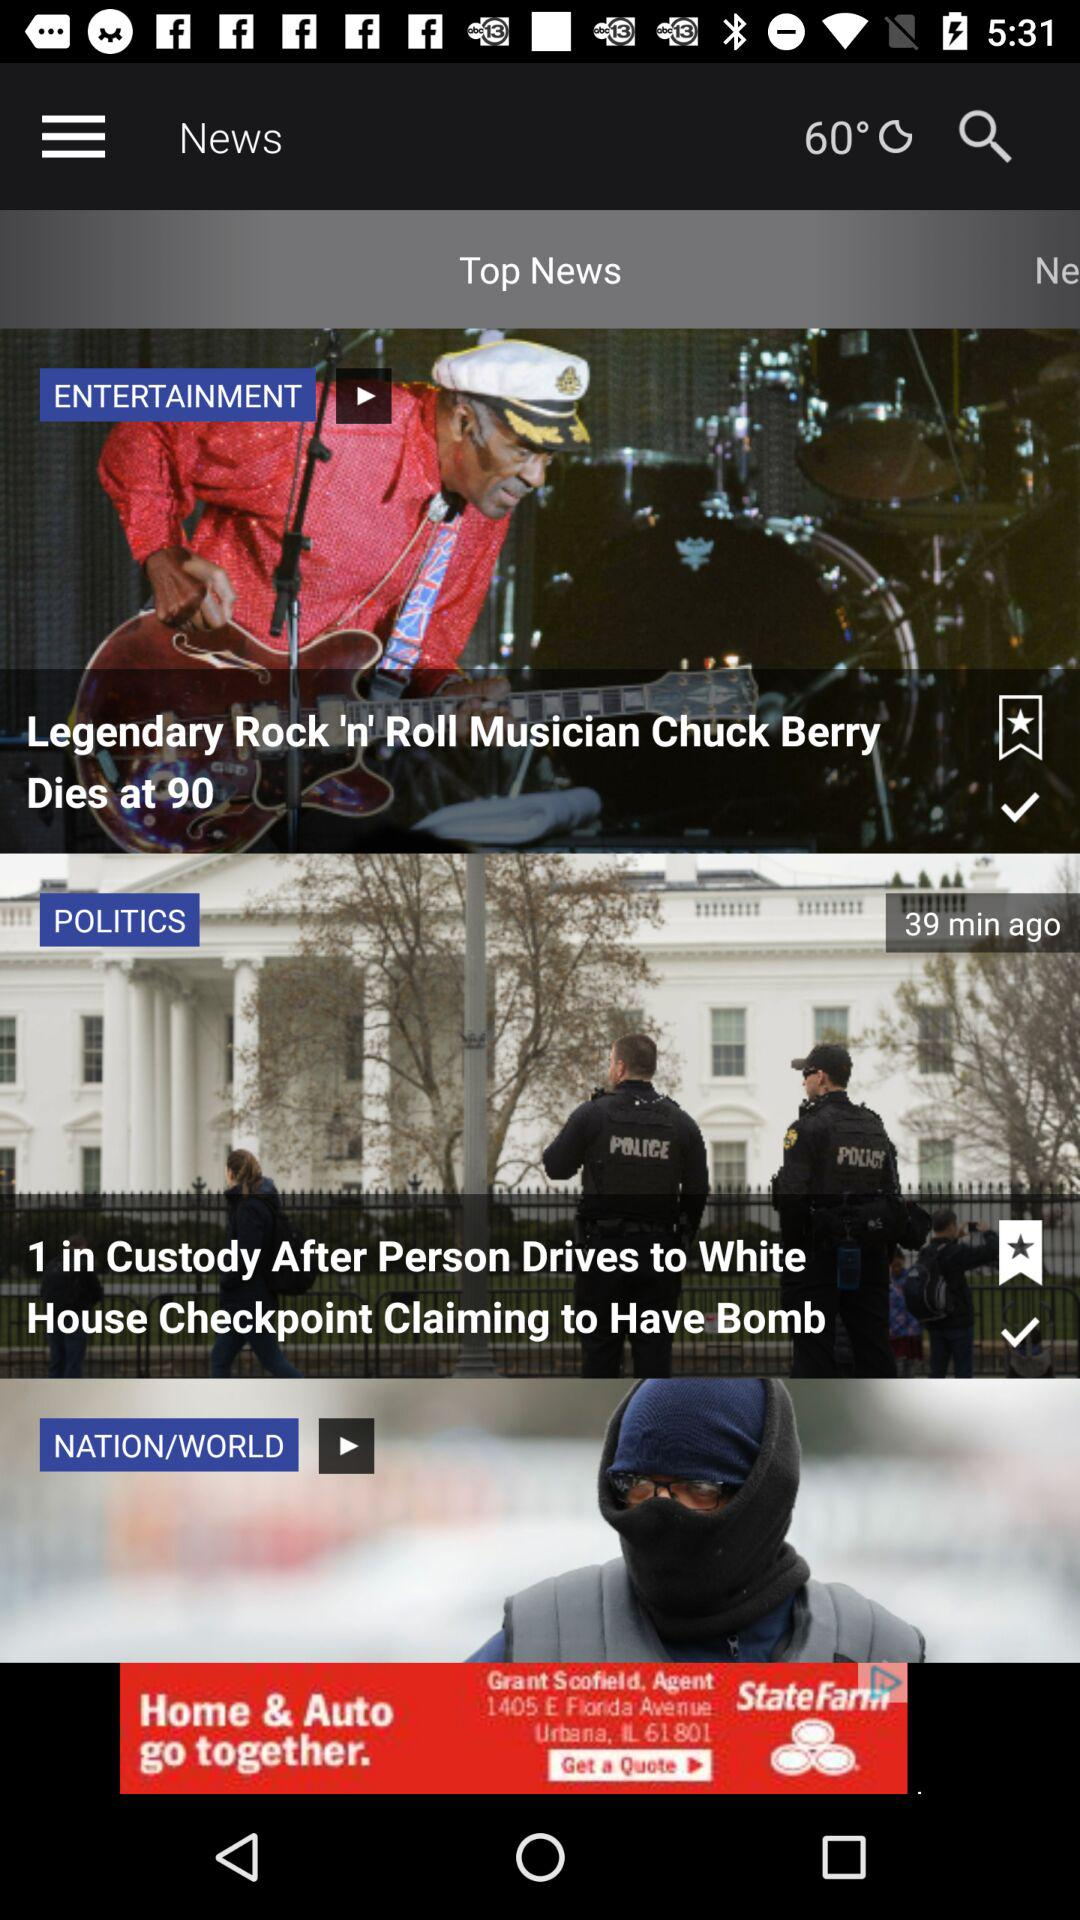What is the selected location?
When the provided information is insufficient, respond with <no answer>. <no answer> 